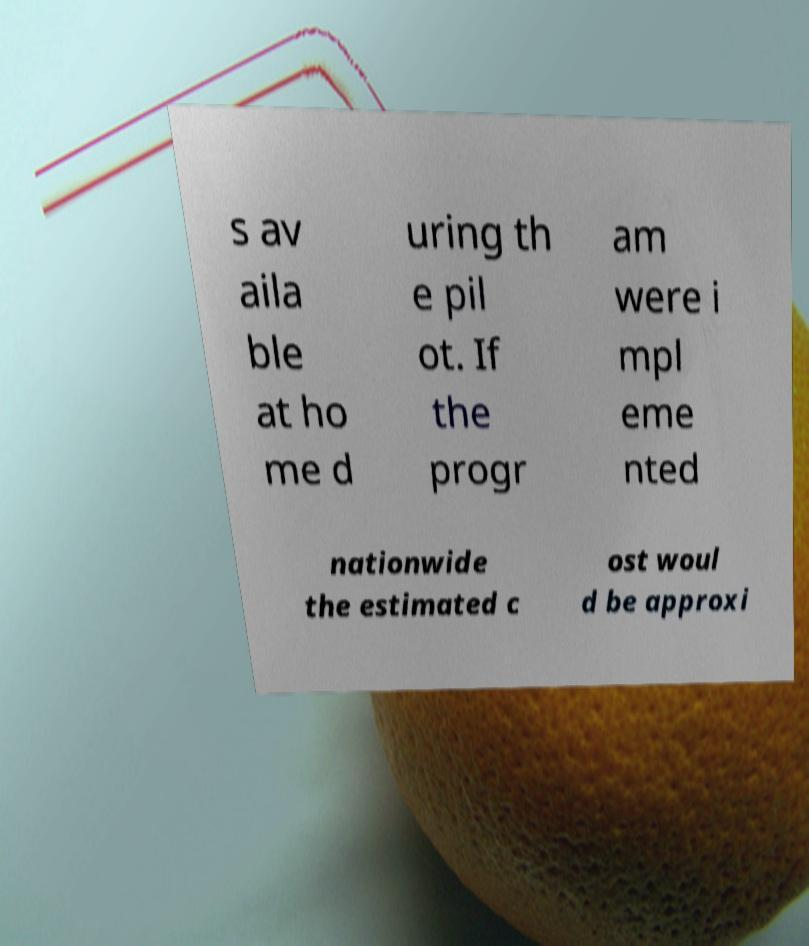Please identify and transcribe the text found in this image. s av aila ble at ho me d uring th e pil ot. If the progr am were i mpl eme nted nationwide the estimated c ost woul d be approxi 